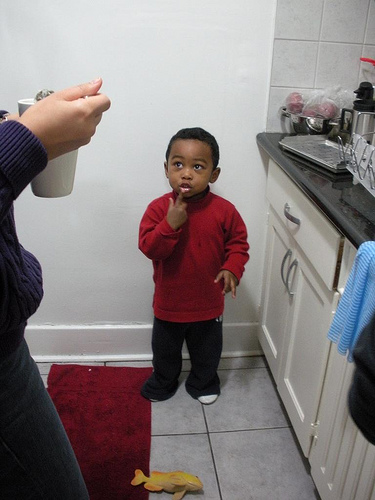<image>
Can you confirm if the kid is behind the adult? No. The kid is not behind the adult. From this viewpoint, the kid appears to be positioned elsewhere in the scene. 